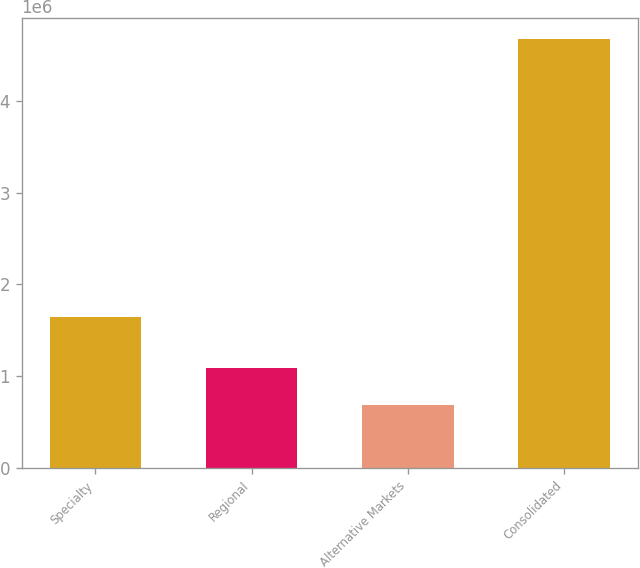Convert chart to OTSL. <chart><loc_0><loc_0><loc_500><loc_500><bar_chart><fcel>Specialty<fcel>Regional<fcel>Alternative Markets<fcel>Consolidated<nl><fcel>1.64647e+06<fcel>1.09022e+06<fcel>680334<fcel>4.67352e+06<nl></chart> 